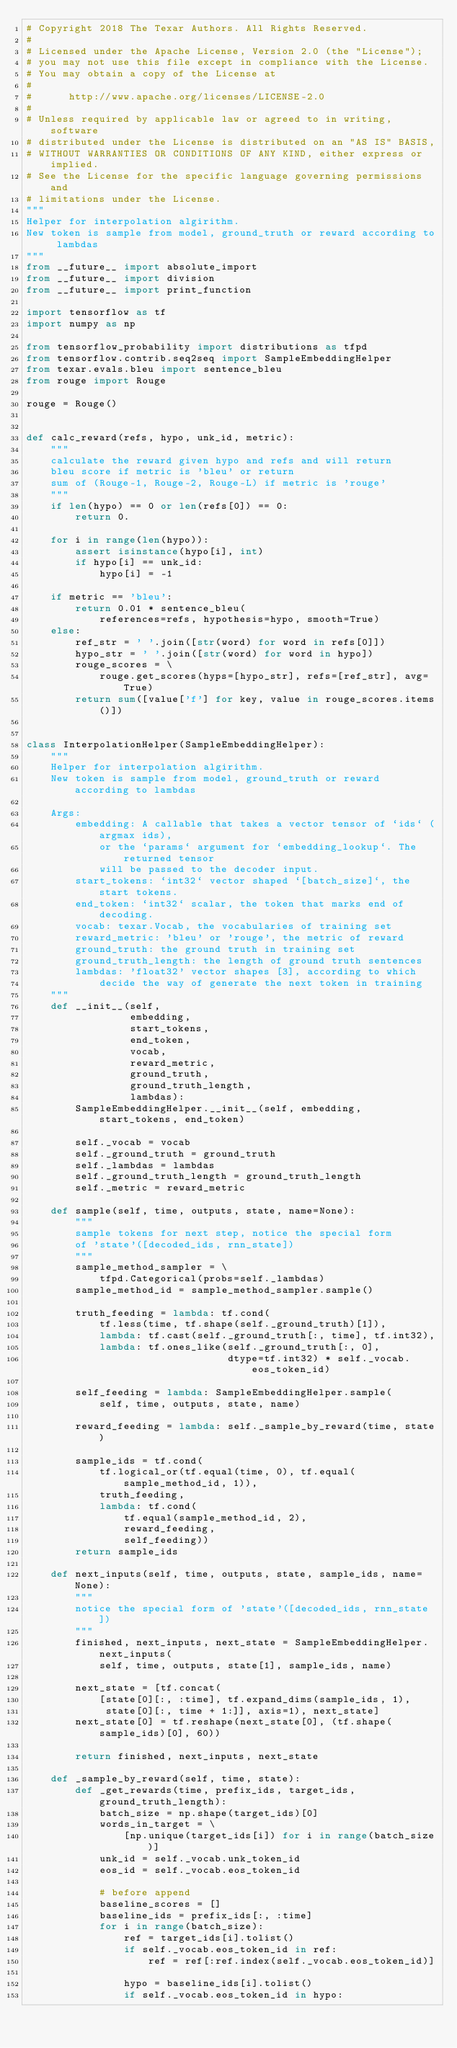<code> <loc_0><loc_0><loc_500><loc_500><_Python_># Copyright 2018 The Texar Authors. All Rights Reserved.
#
# Licensed under the Apache License, Version 2.0 (the "License");
# you may not use this file except in compliance with the License.
# You may obtain a copy of the License at
#
#      http://www.apache.org/licenses/LICENSE-2.0
#
# Unless required by applicable law or agreed to in writing, software
# distributed under the License is distributed on an "AS IS" BASIS,
# WITHOUT WARRANTIES OR CONDITIONS OF ANY KIND, either express or implied.
# See the License for the specific language governing permissions and
# limitations under the License.
"""
Helper for interpolation algirithm.
New token is sample from model, ground_truth or reward according to lambdas
"""
from __future__ import absolute_import
from __future__ import division
from __future__ import print_function

import tensorflow as tf
import numpy as np

from tensorflow_probability import distributions as tfpd
from tensorflow.contrib.seq2seq import SampleEmbeddingHelper
from texar.evals.bleu import sentence_bleu
from rouge import Rouge

rouge = Rouge()


def calc_reward(refs, hypo, unk_id, metric):
    """
    calculate the reward given hypo and refs and will return
    bleu score if metric is 'bleu' or return
    sum of (Rouge-1, Rouge-2, Rouge-L) if metric is 'rouge'
    """
    if len(hypo) == 0 or len(refs[0]) == 0:
        return 0.

    for i in range(len(hypo)):
        assert isinstance(hypo[i], int)
        if hypo[i] == unk_id:
            hypo[i] = -1

    if metric == 'bleu':
        return 0.01 * sentence_bleu(
            references=refs, hypothesis=hypo, smooth=True)
    else:
        ref_str = ' '.join([str(word) for word in refs[0]])
        hypo_str = ' '.join([str(word) for word in hypo])
        rouge_scores = \
            rouge.get_scores(hyps=[hypo_str], refs=[ref_str], avg=True)
        return sum([value['f'] for key, value in rouge_scores.items()])


class InterpolationHelper(SampleEmbeddingHelper):
    """
    Helper for interpolation algirithm.
    New token is sample from model, ground_truth or reward according to lambdas

    Args:
        embedding: A callable that takes a vector tensor of `ids` (argmax ids),
            or the `params` argument for `embedding_lookup`. The returned tensor
            will be passed to the decoder input.
        start_tokens: `int32` vector shaped `[batch_size]`, the start tokens.
        end_token: `int32` scalar, the token that marks end of decoding.
        vocab: texar.Vocab, the vocabularies of training set
        reward_metric: 'bleu' or 'rouge', the metric of reward
        ground_truth: the ground truth in training set
        ground_truth_length: the length of ground truth sentences
        lambdas: 'float32' vector shapes [3], according to which
            decide the way of generate the next token in training
    """
    def __init__(self,
                 embedding,
                 start_tokens,
                 end_token,
                 vocab,
                 reward_metric,
                 ground_truth,
                 ground_truth_length,
                 lambdas):
        SampleEmbeddingHelper.__init__(self, embedding, start_tokens, end_token)

        self._vocab = vocab
        self._ground_truth = ground_truth
        self._lambdas = lambdas
        self._ground_truth_length = ground_truth_length
        self._metric = reward_metric

    def sample(self, time, outputs, state, name=None):
        """
        sample tokens for next step, notice the special form
        of 'state'([decoded_ids, rnn_state])
        """
        sample_method_sampler = \
            tfpd.Categorical(probs=self._lambdas)
        sample_method_id = sample_method_sampler.sample()

        truth_feeding = lambda: tf.cond(
            tf.less(time, tf.shape(self._ground_truth)[1]),
            lambda: tf.cast(self._ground_truth[:, time], tf.int32),
            lambda: tf.ones_like(self._ground_truth[:, 0],
                                 dtype=tf.int32) * self._vocab.eos_token_id)

        self_feeding = lambda: SampleEmbeddingHelper.sample(
            self, time, outputs, state, name)

        reward_feeding = lambda: self._sample_by_reward(time, state)

        sample_ids = tf.cond(
            tf.logical_or(tf.equal(time, 0), tf.equal(sample_method_id, 1)),
            truth_feeding,
            lambda: tf.cond(
                tf.equal(sample_method_id, 2),
                reward_feeding,
                self_feeding))
        return sample_ids

    def next_inputs(self, time, outputs, state, sample_ids, name=None):
        """
        notice the special form of 'state'([decoded_ids, rnn_state])
        """
        finished, next_inputs, next_state = SampleEmbeddingHelper.next_inputs(
            self, time, outputs, state[1], sample_ids, name)

        next_state = [tf.concat(
            [state[0][:, :time], tf.expand_dims(sample_ids, 1),
             state[0][:, time + 1:]], axis=1), next_state]
        next_state[0] = tf.reshape(next_state[0], (tf.shape(sample_ids)[0], 60))

        return finished, next_inputs, next_state

    def _sample_by_reward(self, time, state):
        def _get_rewards(time, prefix_ids, target_ids, ground_truth_length):
            batch_size = np.shape(target_ids)[0]
            words_in_target = \
                [np.unique(target_ids[i]) for i in range(batch_size)]
            unk_id = self._vocab.unk_token_id
            eos_id = self._vocab.eos_token_id

            # before append
            baseline_scores = []
            baseline_ids = prefix_ids[:, :time]
            for i in range(batch_size):
                ref = target_ids[i].tolist()
                if self._vocab.eos_token_id in ref:
                    ref = ref[:ref.index(self._vocab.eos_token_id)]

                hypo = baseline_ids[i].tolist()
                if self._vocab.eos_token_id in hypo:</code> 